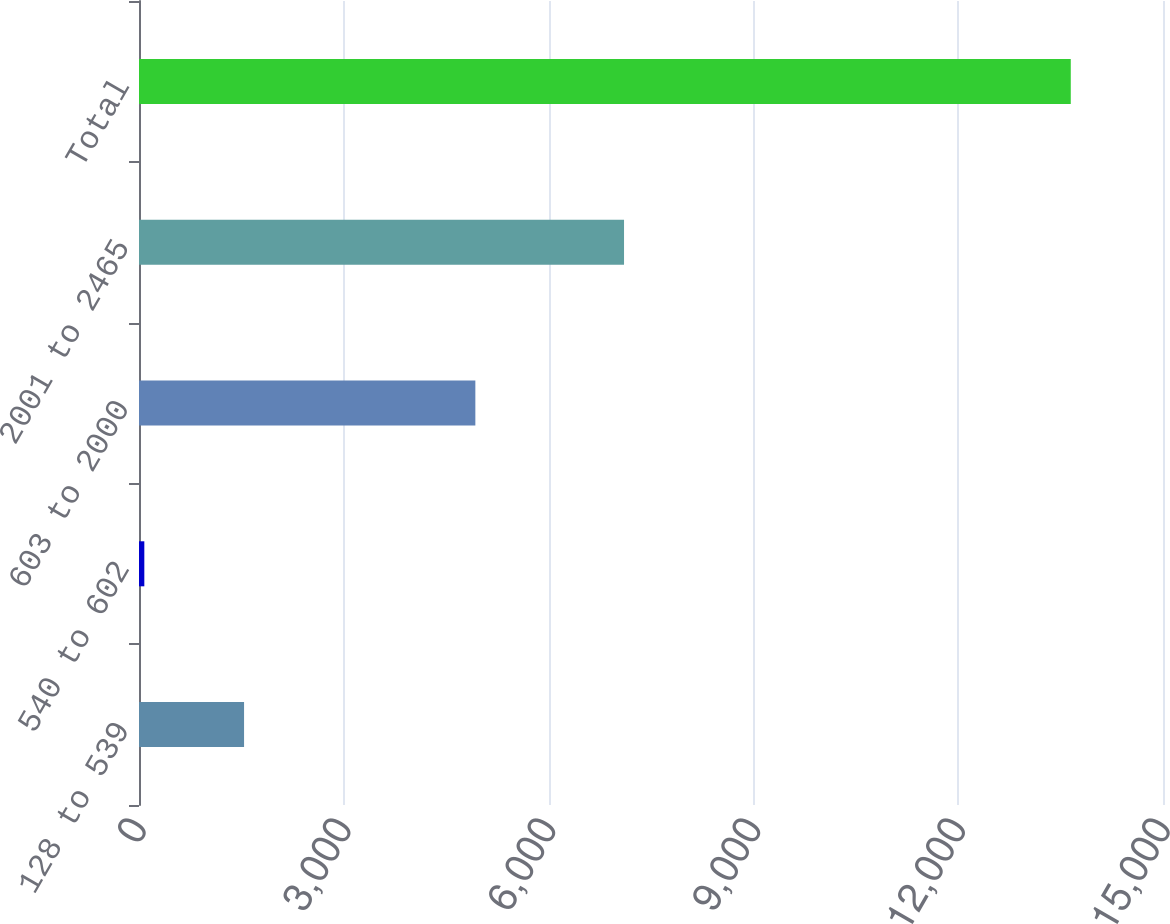Convert chart. <chart><loc_0><loc_0><loc_500><loc_500><bar_chart><fcel>128 to 539<fcel>540 to 602<fcel>603 to 2000<fcel>2001 to 2465<fcel>Total<nl><fcel>1539<fcel>78<fcel>4927<fcel>7105<fcel>13649<nl></chart> 